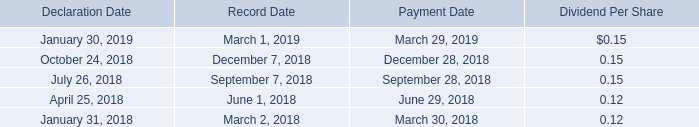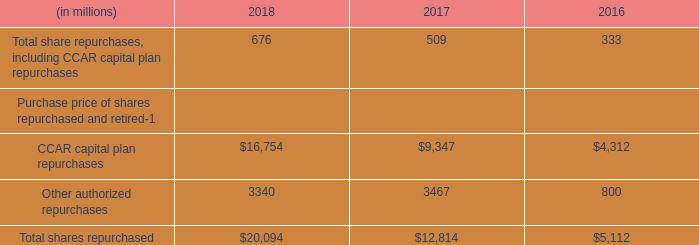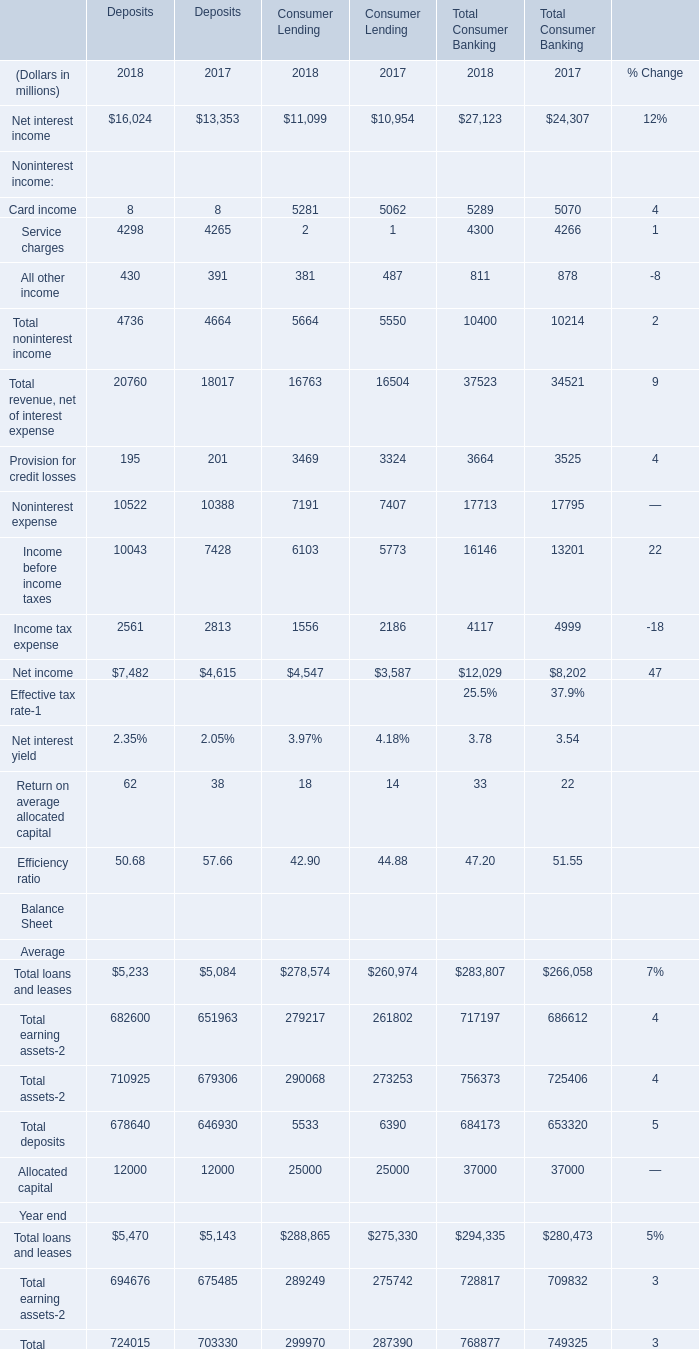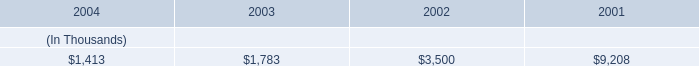what is the net cash flow from money pool activity for entergy new orleans' operating cash flow in the last three years? 
Computations: ((0.4 + 1.7) + 5.7)
Answer: 7.8. 